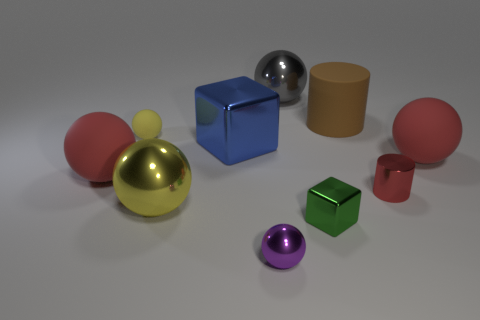Subtract all purple spheres. How many spheres are left? 5 Subtract all tiny purple spheres. How many spheres are left? 5 Subtract all purple balls. Subtract all purple cylinders. How many balls are left? 5 Subtract all cylinders. How many objects are left? 8 Subtract 0 green cylinders. How many objects are left? 10 Subtract all small purple metallic balls. Subtract all big blue metallic objects. How many objects are left? 8 Add 9 small matte spheres. How many small matte spheres are left? 10 Add 2 large brown metallic blocks. How many large brown metallic blocks exist? 2 